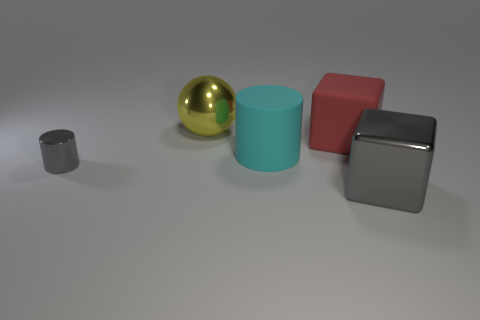There is a small metal thing that is the same color as the big metal cube; what is its shape?
Offer a terse response. Cylinder. How many big red cylinders are there?
Your answer should be very brief. 0. There is a gray object that is the same shape as the big red matte object; what is it made of?
Your response must be concise. Metal. Do the gray object on the left side of the big metal block and the big cyan cylinder have the same material?
Provide a succinct answer. No. Are there more big gray shiny things in front of the ball than large yellow things that are in front of the red thing?
Offer a terse response. Yes. How big is the shiny sphere?
Provide a succinct answer. Large. The big gray thing that is the same material as the yellow thing is what shape?
Provide a short and direct response. Cube. There is a gray object that is on the right side of the large yellow metallic sphere; is it the same shape as the cyan thing?
Your answer should be very brief. No. What number of objects are rubber objects or large red rubber objects?
Make the answer very short. 2. There is a large thing that is on the right side of the big rubber cylinder and behind the shiny block; what material is it?
Offer a very short reply. Rubber. 